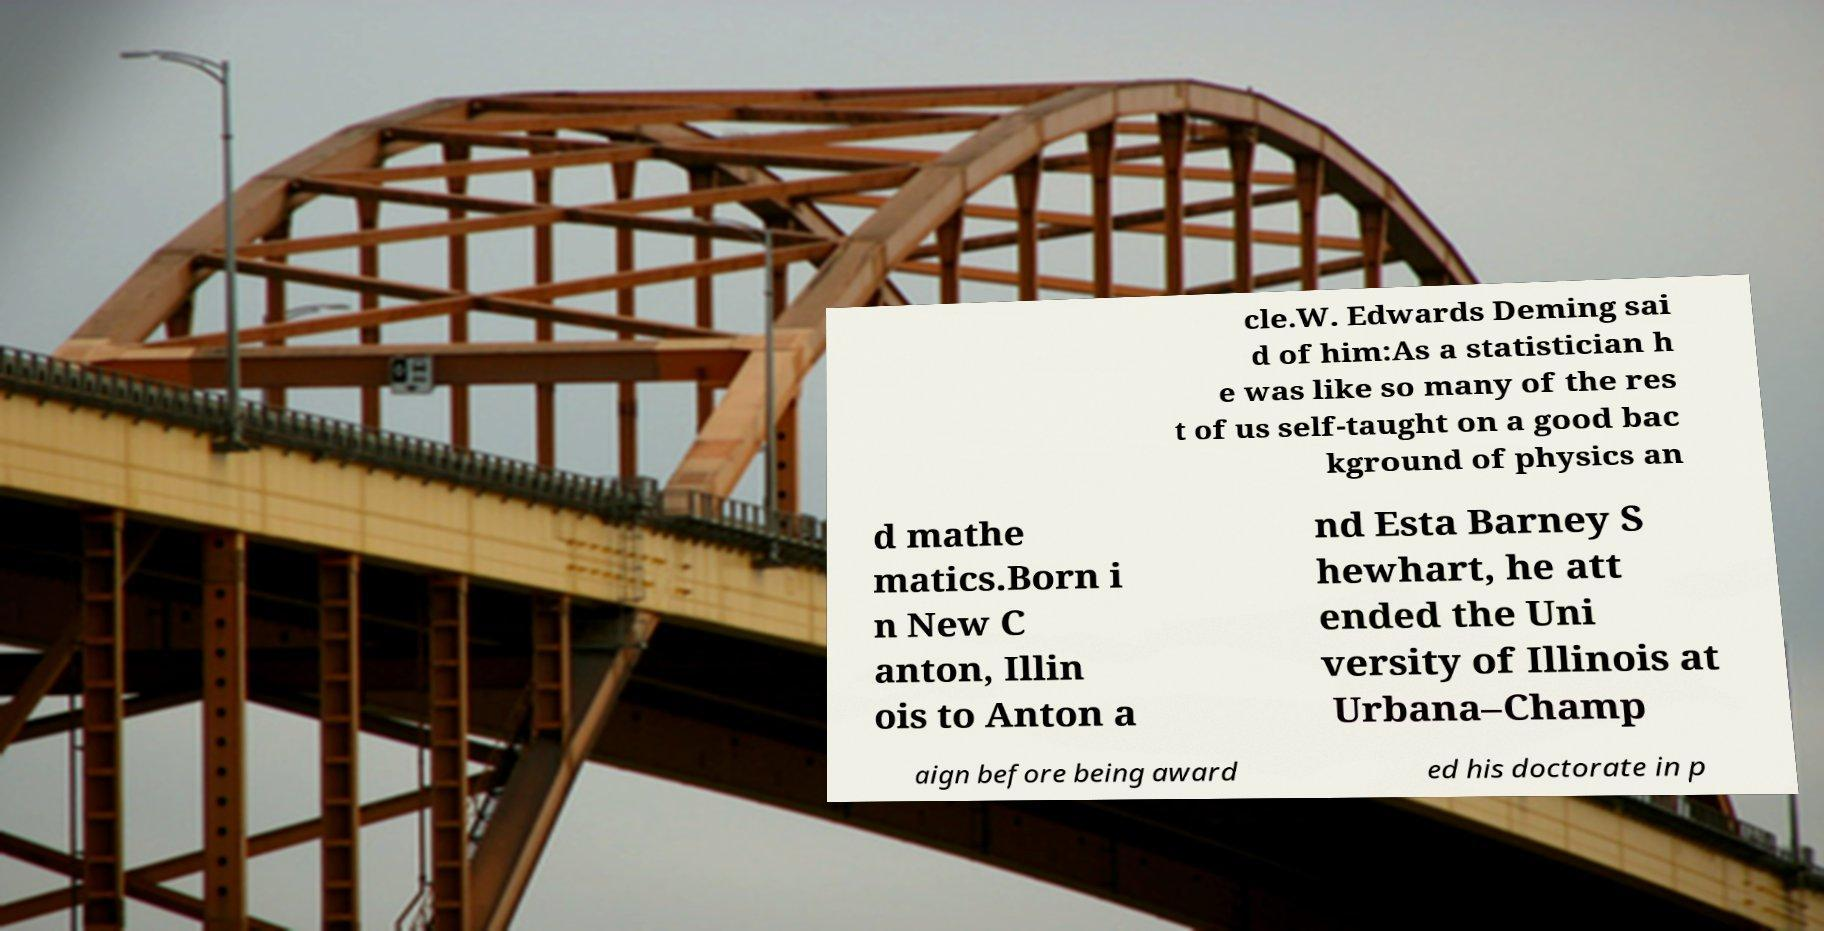Can you accurately transcribe the text from the provided image for me? cle.W. Edwards Deming sai d of him:As a statistician h e was like so many of the res t of us self-taught on a good bac kground of physics an d mathe matics.Born i n New C anton, Illin ois to Anton a nd Esta Barney S hewhart, he att ended the Uni versity of Illinois at Urbana–Champ aign before being award ed his doctorate in p 